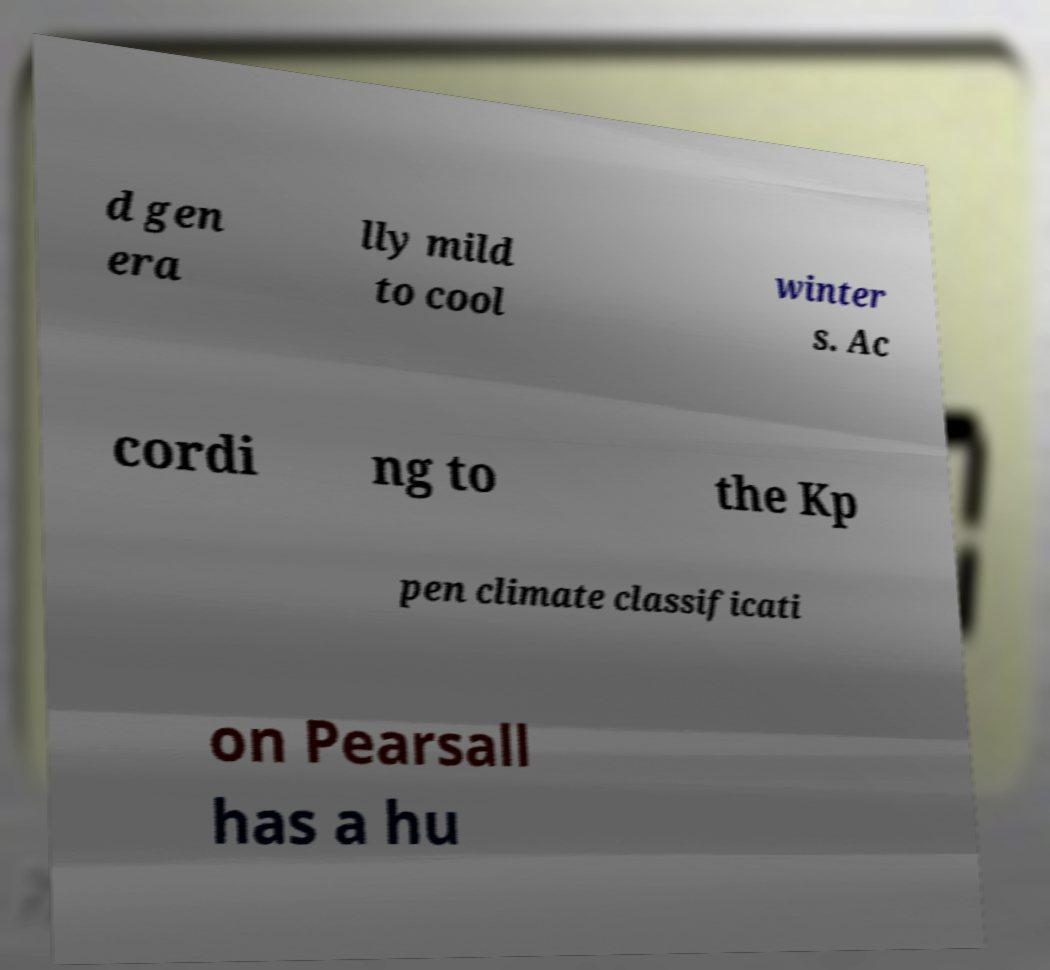Could you assist in decoding the text presented in this image and type it out clearly? d gen era lly mild to cool winter s. Ac cordi ng to the Kp pen climate classificati on Pearsall has a hu 